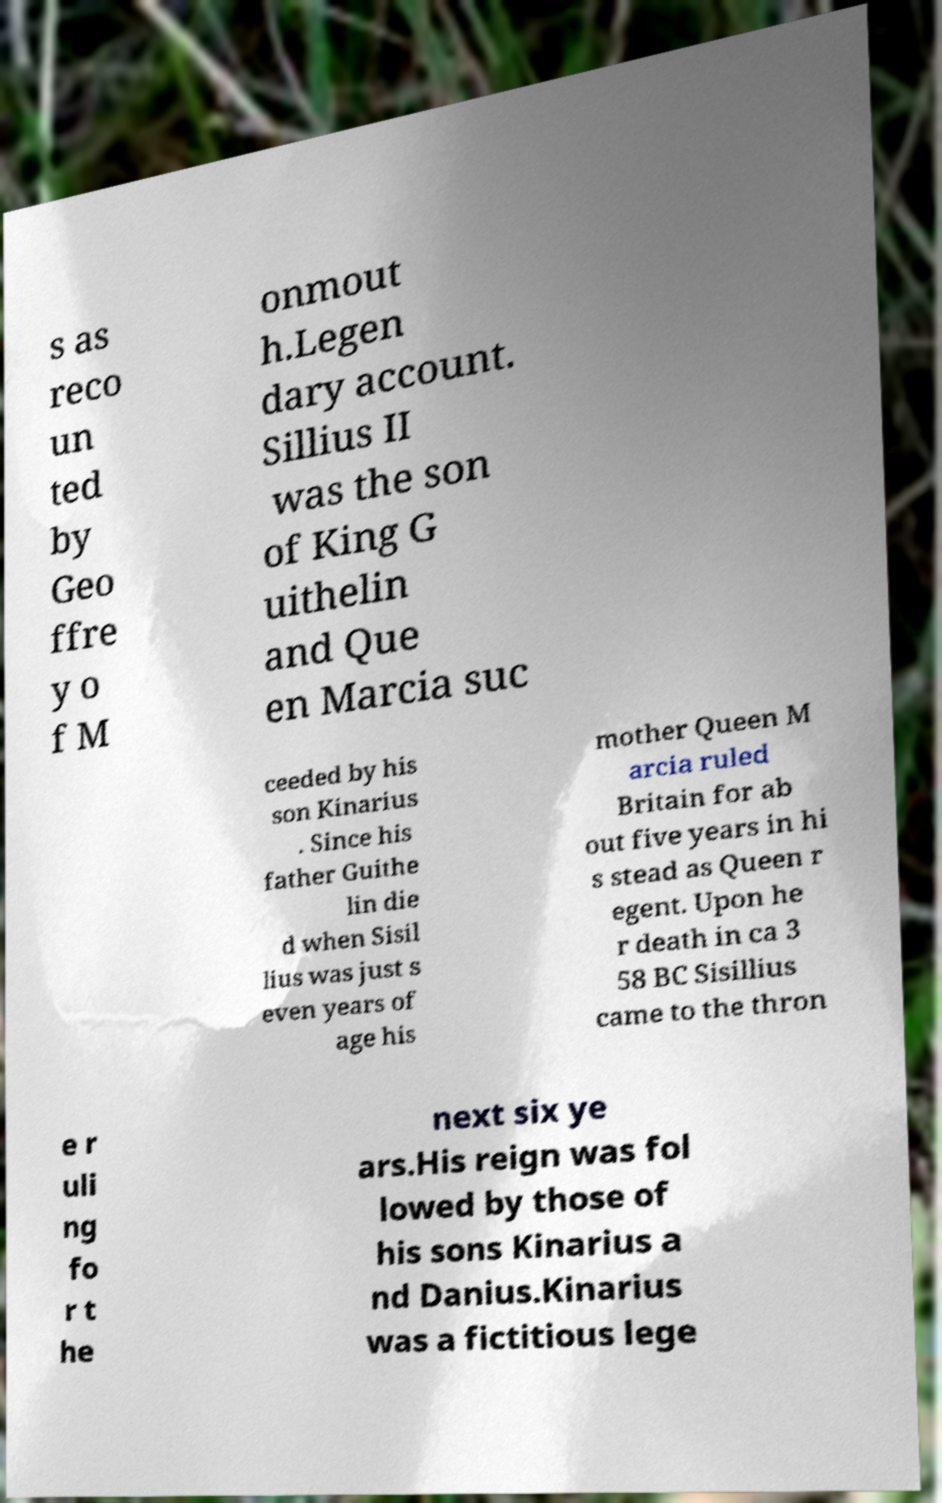I need the written content from this picture converted into text. Can you do that? s as reco un ted by Geo ffre y o f M onmout h.Legen dary account. Sillius II was the son of King G uithelin and Que en Marcia suc ceeded by his son Kinarius . Since his father Guithe lin die d when Sisil lius was just s even years of age his mother Queen M arcia ruled Britain for ab out five years in hi s stead as Queen r egent. Upon he r death in ca 3 58 BC Sisillius came to the thron e r uli ng fo r t he next six ye ars.His reign was fol lowed by those of his sons Kinarius a nd Danius.Kinarius was a fictitious lege 